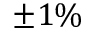Convert formula to latex. <formula><loc_0><loc_0><loc_500><loc_500>\pm 1 \%</formula> 